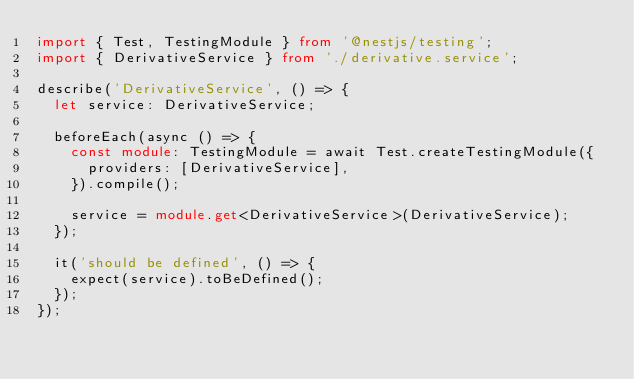<code> <loc_0><loc_0><loc_500><loc_500><_TypeScript_>import { Test, TestingModule } from '@nestjs/testing';
import { DerivativeService } from './derivative.service';

describe('DerivativeService', () => {
  let service: DerivativeService;

  beforeEach(async () => {
    const module: TestingModule = await Test.createTestingModule({
      providers: [DerivativeService],
    }).compile();

    service = module.get<DerivativeService>(DerivativeService);
  });

  it('should be defined', () => {
    expect(service).toBeDefined();
  });
});
</code> 